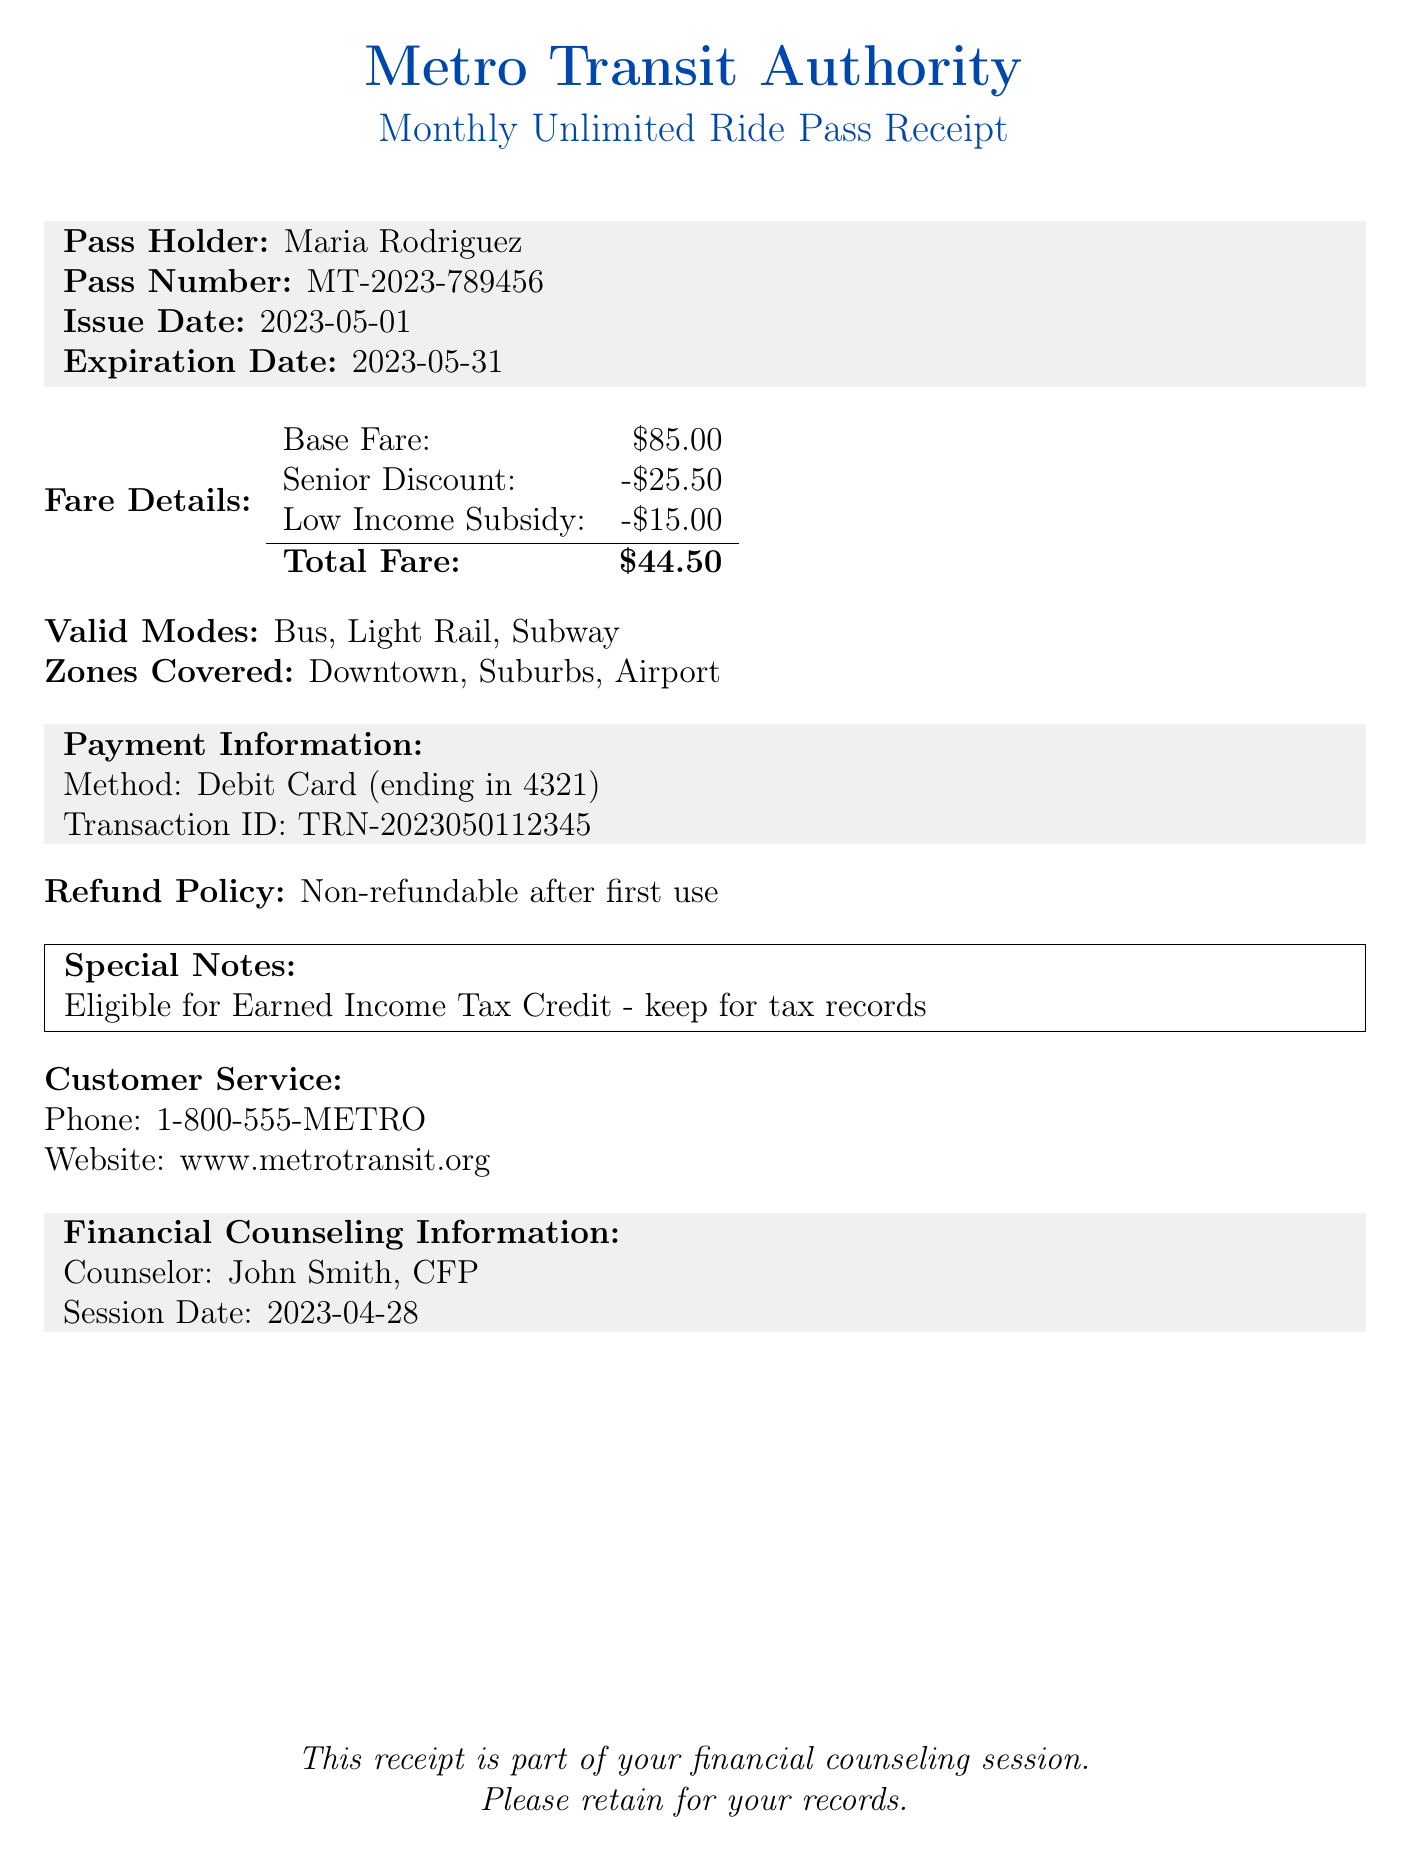What is the pass holder's name? The pass holder's name is listed in the receipt as Maria Rodriguez.
Answer: Maria Rodriguez What is the total fare after discounts? The total fare is calculated after applying the senior discount and low income subsidy to the base fare. The total comes to $44.50.
Answer: $44.50 What is the expiration date of the pass? The expiration date is clearly stated on the receipt and is May 31, 2023.
Answer: 2023-05-31 Which payment method was used? The payment method used for purchasing the pass is specified in the receipt. It mentions "Debit Card (ending in 4321)".
Answer: Debit Card (ending in 4321) What are the valid modes of transportation? The receipt lists the modes of transport that the pass covers; these are bus, light rail, and subway.
Answer: Bus, Light Rail, Subway What is the refund policy for the pass? The refund policy explains that the pass is non-refundable after the first use.
Answer: Non-refundable after first use What are the zones covered by the pass? The zones that the pass covers are detailed, including Downtown, Suburbs, and Airport.
Answer: Downtown, Suburbs, Airport Who is the financial counselor? The name of the financial counselor is stated in the document and is John Smith, CFP.
Answer: John Smith, CFP Is this receipt eligible for tax credits? The special notes section indicates that the receipt is eligible for the Earned Income Tax Credit, necessitating its retention for tax records.
Answer: Yes 